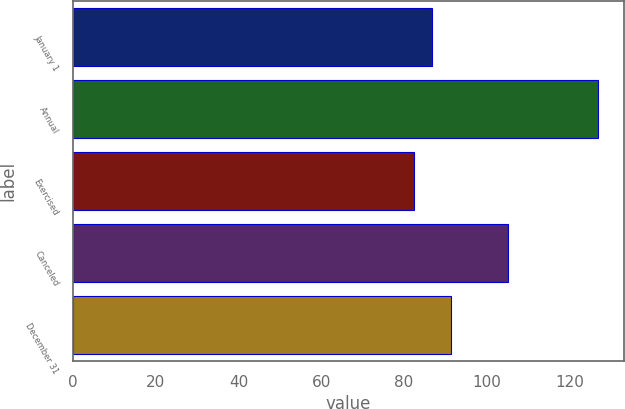Convert chart. <chart><loc_0><loc_0><loc_500><loc_500><bar_chart><fcel>January 1<fcel>Annual<fcel>Exercised<fcel>Canceled<fcel>December 31<nl><fcel>86.81<fcel>126.77<fcel>82.37<fcel>105.11<fcel>91.25<nl></chart> 